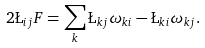Convert formula to latex. <formula><loc_0><loc_0><loc_500><loc_500>2 \L _ { i j } F = \sum _ { k } \L _ { k j } \omega _ { k i } - \L _ { k i } \omega _ { k j } .</formula> 